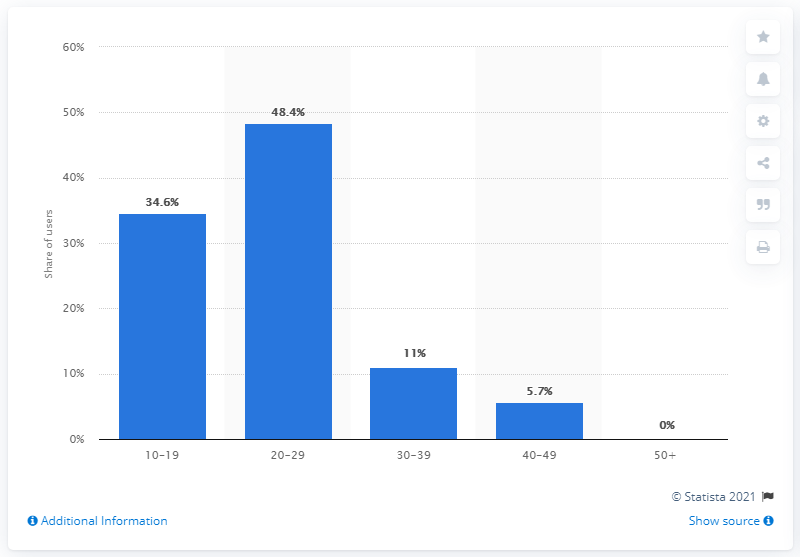Point out several critical features in this image. In March 2021, approximately 34.6% of Depop's active users were teenagers. 